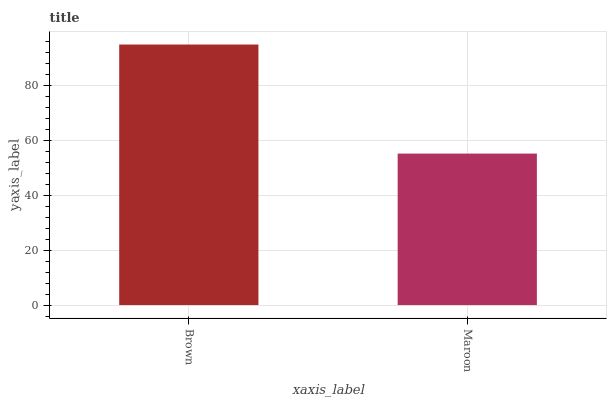Is Maroon the maximum?
Answer yes or no. No. Is Brown greater than Maroon?
Answer yes or no. Yes. Is Maroon less than Brown?
Answer yes or no. Yes. Is Maroon greater than Brown?
Answer yes or no. No. Is Brown less than Maroon?
Answer yes or no. No. Is Brown the high median?
Answer yes or no. Yes. Is Maroon the low median?
Answer yes or no. Yes. Is Maroon the high median?
Answer yes or no. No. Is Brown the low median?
Answer yes or no. No. 